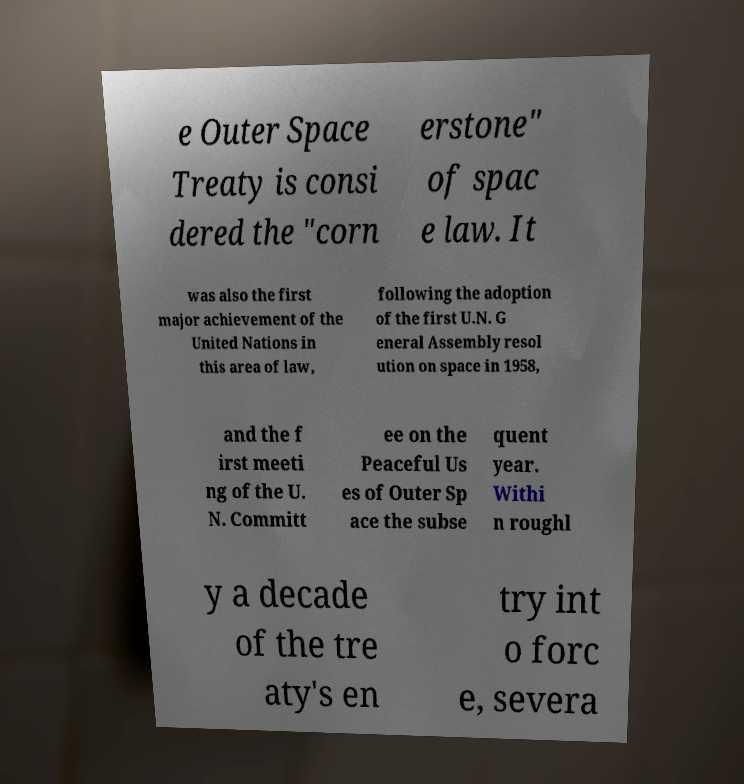There's text embedded in this image that I need extracted. Can you transcribe it verbatim? e Outer Space Treaty is consi dered the "corn erstone" of spac e law. It was also the first major achievement of the United Nations in this area of law, following the adoption of the first U.N. G eneral Assembly resol ution on space in 1958, and the f irst meeti ng of the U. N. Committ ee on the Peaceful Us es of Outer Sp ace the subse quent year. Withi n roughl y a decade of the tre aty's en try int o forc e, severa 